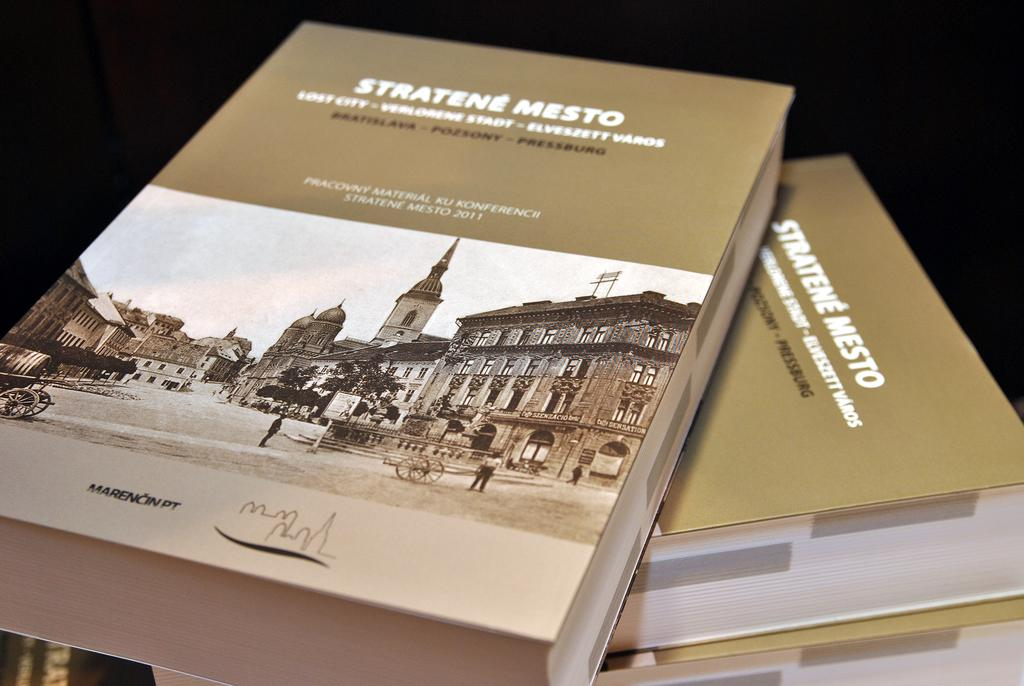<image>
Present a compact description of the photo's key features. a book that has the title Stratene Mesto in it 